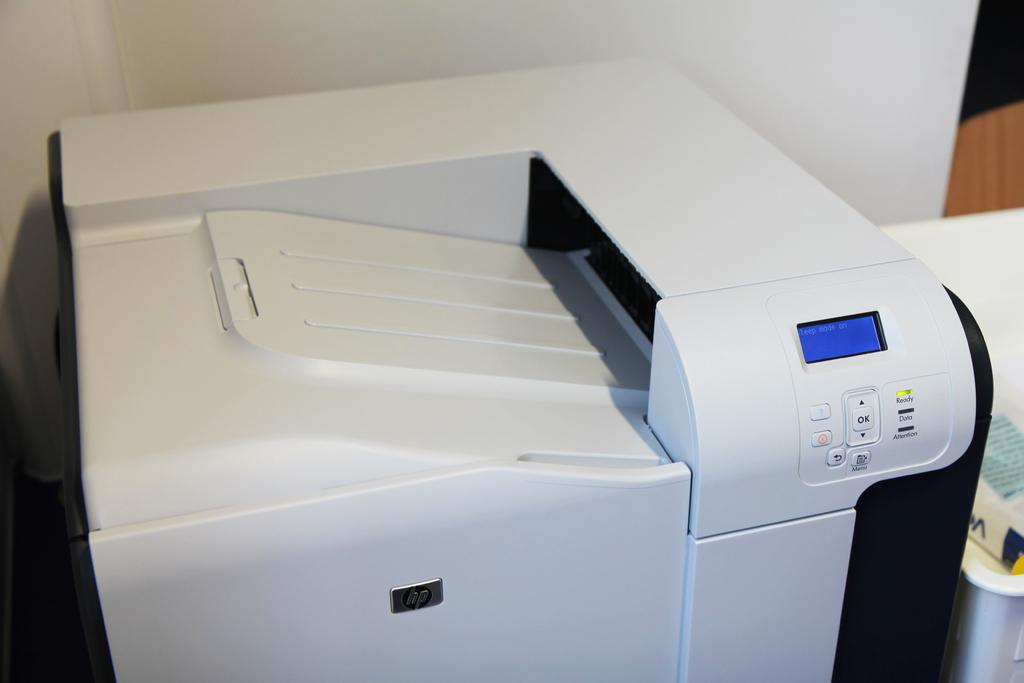<image>
Provide a brief description of the given image. An HP brand printer has a blue digital display screen. 